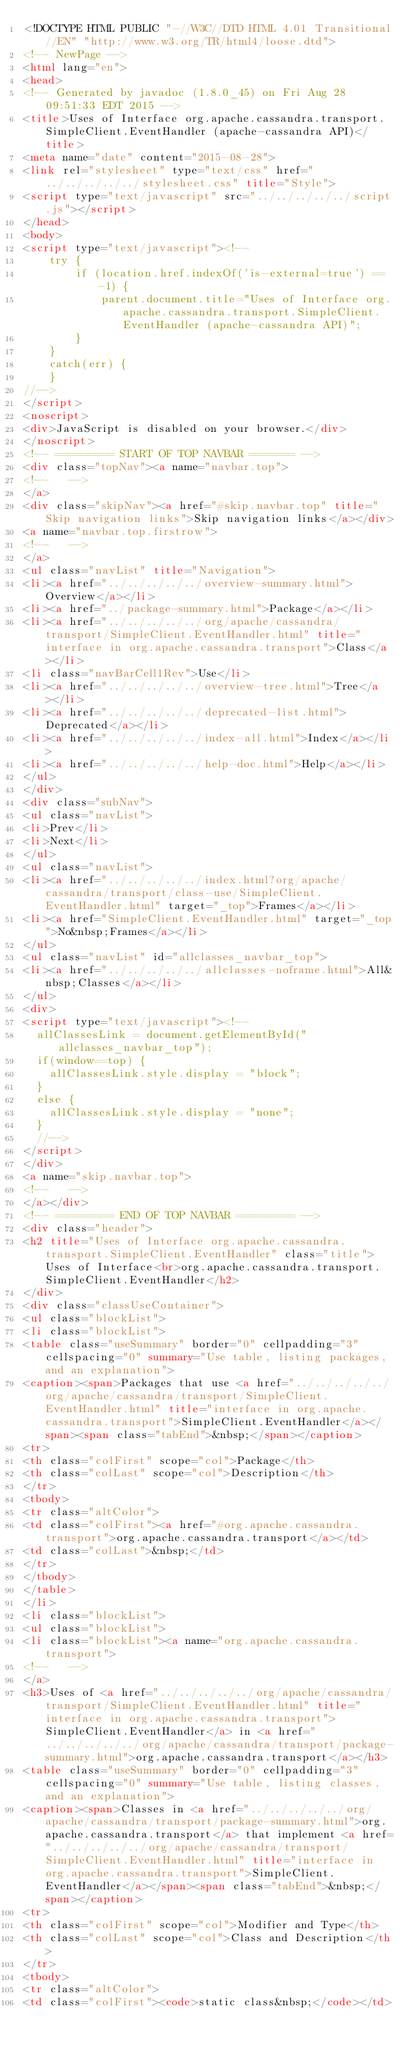Convert code to text. <code><loc_0><loc_0><loc_500><loc_500><_HTML_><!DOCTYPE HTML PUBLIC "-//W3C//DTD HTML 4.01 Transitional//EN" "http://www.w3.org/TR/html4/loose.dtd">
<!-- NewPage -->
<html lang="en">
<head>
<!-- Generated by javadoc (1.8.0_45) on Fri Aug 28 09:51:33 EDT 2015 -->
<title>Uses of Interface org.apache.cassandra.transport.SimpleClient.EventHandler (apache-cassandra API)</title>
<meta name="date" content="2015-08-28">
<link rel="stylesheet" type="text/css" href="../../../../../stylesheet.css" title="Style">
<script type="text/javascript" src="../../../../../script.js"></script>
</head>
<body>
<script type="text/javascript"><!--
    try {
        if (location.href.indexOf('is-external=true') == -1) {
            parent.document.title="Uses of Interface org.apache.cassandra.transport.SimpleClient.EventHandler (apache-cassandra API)";
        }
    }
    catch(err) {
    }
//-->
</script>
<noscript>
<div>JavaScript is disabled on your browser.</div>
</noscript>
<!-- ========= START OF TOP NAVBAR ======= -->
<div class="topNav"><a name="navbar.top">
<!--   -->
</a>
<div class="skipNav"><a href="#skip.navbar.top" title="Skip navigation links">Skip navigation links</a></div>
<a name="navbar.top.firstrow">
<!--   -->
</a>
<ul class="navList" title="Navigation">
<li><a href="../../../../../overview-summary.html">Overview</a></li>
<li><a href="../package-summary.html">Package</a></li>
<li><a href="../../../../../org/apache/cassandra/transport/SimpleClient.EventHandler.html" title="interface in org.apache.cassandra.transport">Class</a></li>
<li class="navBarCell1Rev">Use</li>
<li><a href="../../../../../overview-tree.html">Tree</a></li>
<li><a href="../../../../../deprecated-list.html">Deprecated</a></li>
<li><a href="../../../../../index-all.html">Index</a></li>
<li><a href="../../../../../help-doc.html">Help</a></li>
</ul>
</div>
<div class="subNav">
<ul class="navList">
<li>Prev</li>
<li>Next</li>
</ul>
<ul class="navList">
<li><a href="../../../../../index.html?org/apache/cassandra/transport/class-use/SimpleClient.EventHandler.html" target="_top">Frames</a></li>
<li><a href="SimpleClient.EventHandler.html" target="_top">No&nbsp;Frames</a></li>
</ul>
<ul class="navList" id="allclasses_navbar_top">
<li><a href="../../../../../allclasses-noframe.html">All&nbsp;Classes</a></li>
</ul>
<div>
<script type="text/javascript"><!--
  allClassesLink = document.getElementById("allclasses_navbar_top");
  if(window==top) {
    allClassesLink.style.display = "block";
  }
  else {
    allClassesLink.style.display = "none";
  }
  //-->
</script>
</div>
<a name="skip.navbar.top">
<!--   -->
</a></div>
<!-- ========= END OF TOP NAVBAR ========= -->
<div class="header">
<h2 title="Uses of Interface org.apache.cassandra.transport.SimpleClient.EventHandler" class="title">Uses of Interface<br>org.apache.cassandra.transport.SimpleClient.EventHandler</h2>
</div>
<div class="classUseContainer">
<ul class="blockList">
<li class="blockList">
<table class="useSummary" border="0" cellpadding="3" cellspacing="0" summary="Use table, listing packages, and an explanation">
<caption><span>Packages that use <a href="../../../../../org/apache/cassandra/transport/SimpleClient.EventHandler.html" title="interface in org.apache.cassandra.transport">SimpleClient.EventHandler</a></span><span class="tabEnd">&nbsp;</span></caption>
<tr>
<th class="colFirst" scope="col">Package</th>
<th class="colLast" scope="col">Description</th>
</tr>
<tbody>
<tr class="altColor">
<td class="colFirst"><a href="#org.apache.cassandra.transport">org.apache.cassandra.transport</a></td>
<td class="colLast">&nbsp;</td>
</tr>
</tbody>
</table>
</li>
<li class="blockList">
<ul class="blockList">
<li class="blockList"><a name="org.apache.cassandra.transport">
<!--   -->
</a>
<h3>Uses of <a href="../../../../../org/apache/cassandra/transport/SimpleClient.EventHandler.html" title="interface in org.apache.cassandra.transport">SimpleClient.EventHandler</a> in <a href="../../../../../org/apache/cassandra/transport/package-summary.html">org.apache.cassandra.transport</a></h3>
<table class="useSummary" border="0" cellpadding="3" cellspacing="0" summary="Use table, listing classes, and an explanation">
<caption><span>Classes in <a href="../../../../../org/apache/cassandra/transport/package-summary.html">org.apache.cassandra.transport</a> that implement <a href="../../../../../org/apache/cassandra/transport/SimpleClient.EventHandler.html" title="interface in org.apache.cassandra.transport">SimpleClient.EventHandler</a></span><span class="tabEnd">&nbsp;</span></caption>
<tr>
<th class="colFirst" scope="col">Modifier and Type</th>
<th class="colLast" scope="col">Class and Description</th>
</tr>
<tbody>
<tr class="altColor">
<td class="colFirst"><code>static class&nbsp;</code></td></code> 